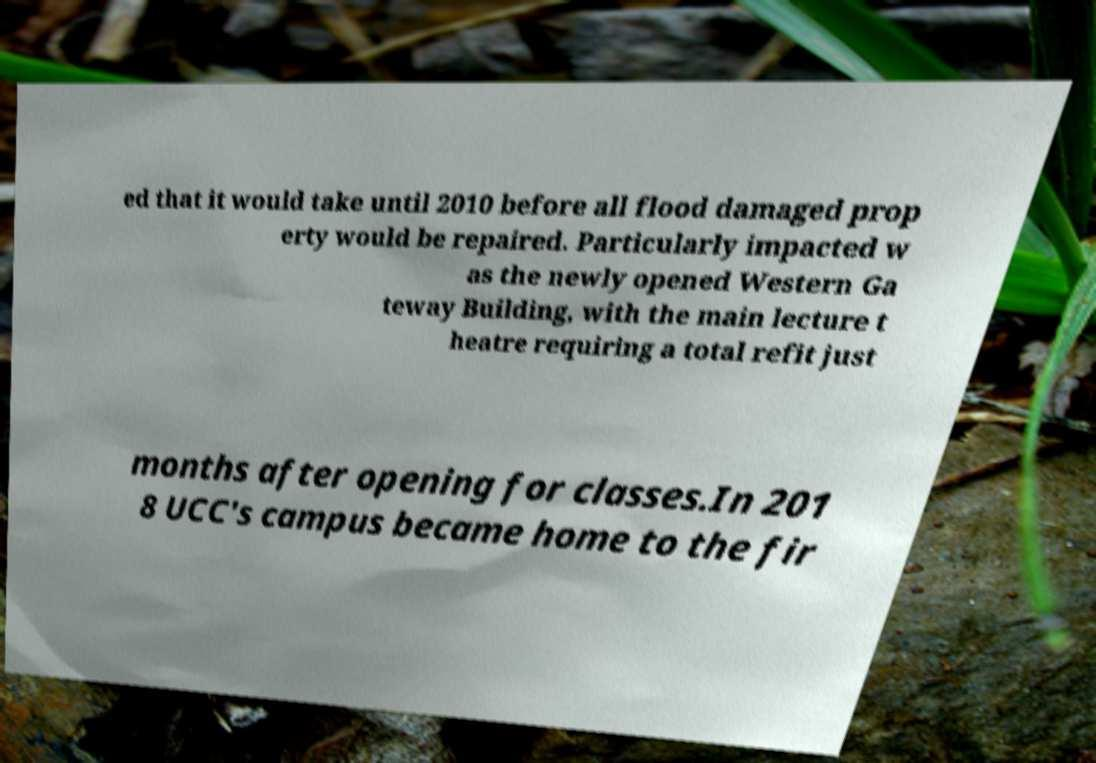Could you assist in decoding the text presented in this image and type it out clearly? ed that it would take until 2010 before all flood damaged prop erty would be repaired. Particularly impacted w as the newly opened Western Ga teway Building, with the main lecture t heatre requiring a total refit just months after opening for classes.In 201 8 UCC's campus became home to the fir 